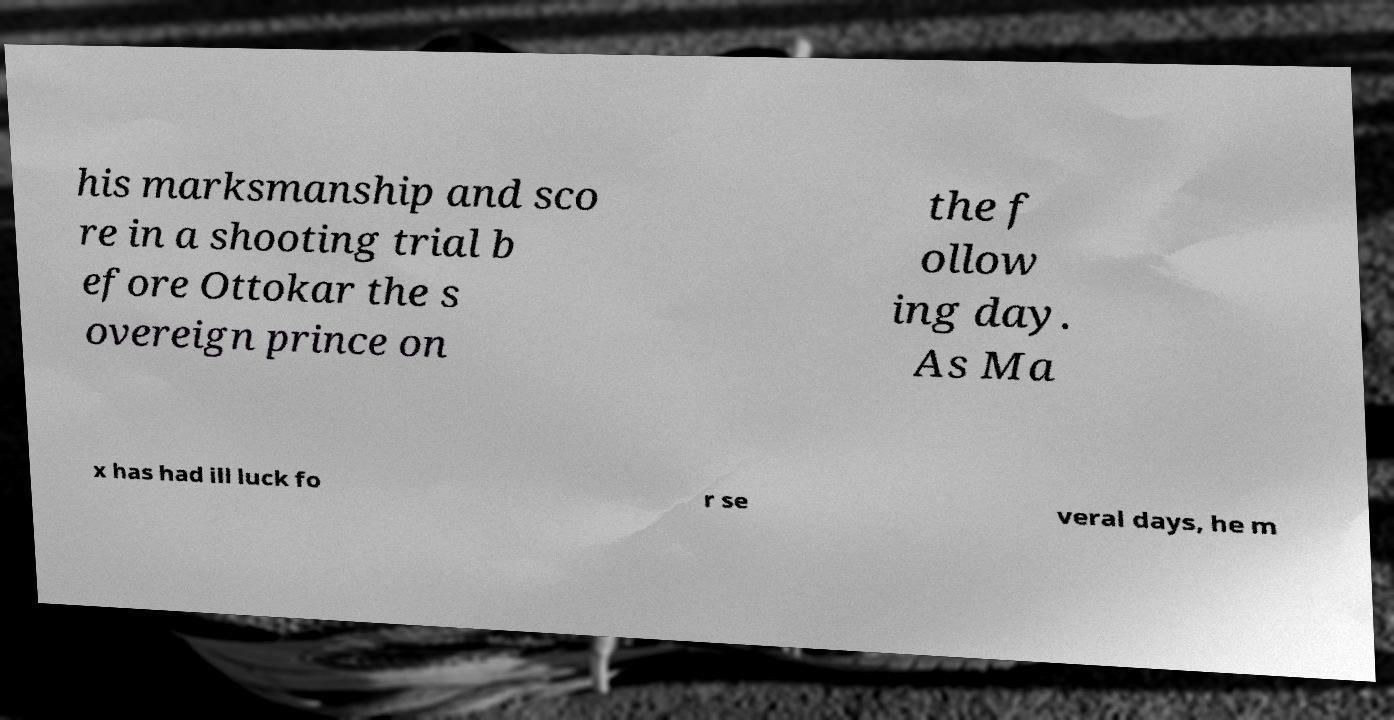I need the written content from this picture converted into text. Can you do that? his marksmanship and sco re in a shooting trial b efore Ottokar the s overeign prince on the f ollow ing day. As Ma x has had ill luck fo r se veral days, he m 